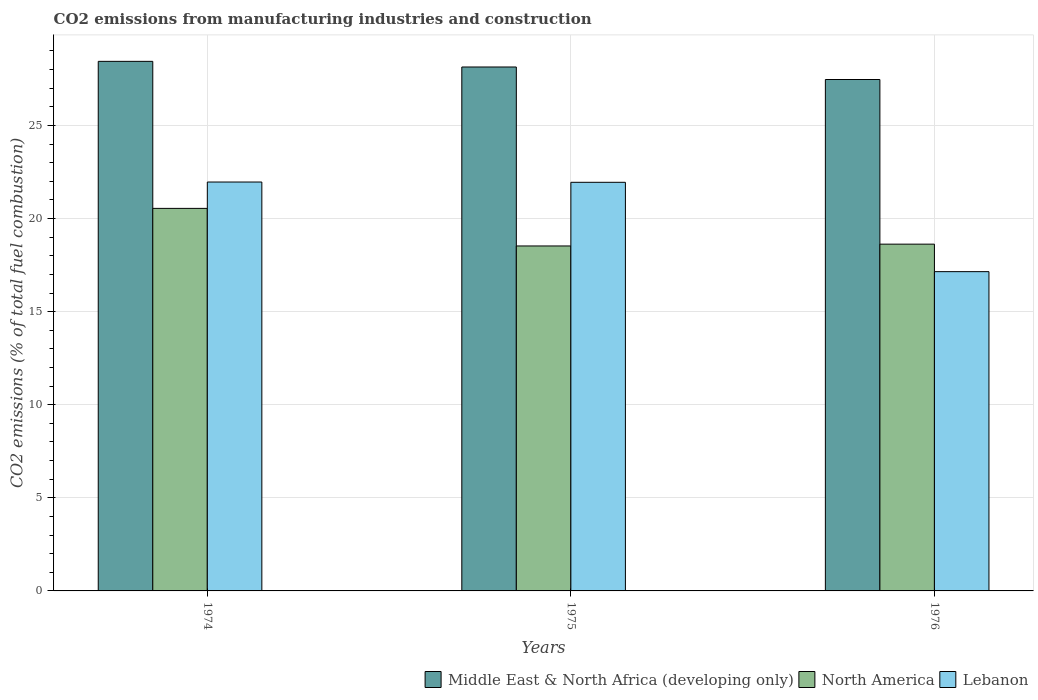How many different coloured bars are there?
Provide a short and direct response. 3. How many groups of bars are there?
Offer a very short reply. 3. Are the number of bars on each tick of the X-axis equal?
Ensure brevity in your answer.  Yes. What is the label of the 2nd group of bars from the left?
Offer a terse response. 1975. What is the amount of CO2 emitted in Lebanon in 1974?
Your answer should be very brief. 21.96. Across all years, what is the maximum amount of CO2 emitted in Middle East & North Africa (developing only)?
Provide a succinct answer. 28.44. Across all years, what is the minimum amount of CO2 emitted in Lebanon?
Keep it short and to the point. 17.15. In which year was the amount of CO2 emitted in North America maximum?
Provide a short and direct response. 1974. In which year was the amount of CO2 emitted in Lebanon minimum?
Your answer should be very brief. 1976. What is the total amount of CO2 emitted in Lebanon in the graph?
Offer a very short reply. 61.06. What is the difference between the amount of CO2 emitted in North America in 1974 and that in 1976?
Make the answer very short. 1.92. What is the difference between the amount of CO2 emitted in Middle East & North Africa (developing only) in 1975 and the amount of CO2 emitted in Lebanon in 1974?
Provide a succinct answer. 6.18. What is the average amount of CO2 emitted in Middle East & North Africa (developing only) per year?
Keep it short and to the point. 28.02. In the year 1975, what is the difference between the amount of CO2 emitted in Lebanon and amount of CO2 emitted in Middle East & North Africa (developing only)?
Provide a short and direct response. -6.19. In how many years, is the amount of CO2 emitted in Lebanon greater than 23 %?
Give a very brief answer. 0. What is the ratio of the amount of CO2 emitted in North America in 1975 to that in 1976?
Give a very brief answer. 0.99. Is the difference between the amount of CO2 emitted in Lebanon in 1974 and 1975 greater than the difference between the amount of CO2 emitted in Middle East & North Africa (developing only) in 1974 and 1975?
Keep it short and to the point. No. What is the difference between the highest and the second highest amount of CO2 emitted in Middle East & North Africa (developing only)?
Your response must be concise. 0.3. What is the difference between the highest and the lowest amount of CO2 emitted in Middle East & North Africa (developing only)?
Keep it short and to the point. 0.98. What does the 3rd bar from the right in 1974 represents?
Your answer should be very brief. Middle East & North Africa (developing only). How many years are there in the graph?
Keep it short and to the point. 3. Are the values on the major ticks of Y-axis written in scientific E-notation?
Your response must be concise. No. How many legend labels are there?
Your response must be concise. 3. How are the legend labels stacked?
Ensure brevity in your answer.  Horizontal. What is the title of the graph?
Keep it short and to the point. CO2 emissions from manufacturing industries and construction. Does "Gambia, The" appear as one of the legend labels in the graph?
Provide a succinct answer. No. What is the label or title of the Y-axis?
Give a very brief answer. CO2 emissions (% of total fuel combustion). What is the CO2 emissions (% of total fuel combustion) in Middle East & North Africa (developing only) in 1974?
Keep it short and to the point. 28.44. What is the CO2 emissions (% of total fuel combustion) of North America in 1974?
Keep it short and to the point. 20.55. What is the CO2 emissions (% of total fuel combustion) in Lebanon in 1974?
Your answer should be very brief. 21.96. What is the CO2 emissions (% of total fuel combustion) in Middle East & North Africa (developing only) in 1975?
Your answer should be compact. 28.14. What is the CO2 emissions (% of total fuel combustion) of North America in 1975?
Your response must be concise. 18.53. What is the CO2 emissions (% of total fuel combustion) of Lebanon in 1975?
Your answer should be very brief. 21.95. What is the CO2 emissions (% of total fuel combustion) of Middle East & North Africa (developing only) in 1976?
Offer a very short reply. 27.47. What is the CO2 emissions (% of total fuel combustion) in North America in 1976?
Make the answer very short. 18.63. What is the CO2 emissions (% of total fuel combustion) of Lebanon in 1976?
Offer a terse response. 17.15. Across all years, what is the maximum CO2 emissions (% of total fuel combustion) of Middle East & North Africa (developing only)?
Keep it short and to the point. 28.44. Across all years, what is the maximum CO2 emissions (% of total fuel combustion) in North America?
Provide a succinct answer. 20.55. Across all years, what is the maximum CO2 emissions (% of total fuel combustion) in Lebanon?
Offer a terse response. 21.96. Across all years, what is the minimum CO2 emissions (% of total fuel combustion) in Middle East & North Africa (developing only)?
Your answer should be very brief. 27.47. Across all years, what is the minimum CO2 emissions (% of total fuel combustion) of North America?
Keep it short and to the point. 18.53. Across all years, what is the minimum CO2 emissions (% of total fuel combustion) of Lebanon?
Keep it short and to the point. 17.15. What is the total CO2 emissions (% of total fuel combustion) of Middle East & North Africa (developing only) in the graph?
Make the answer very short. 84.05. What is the total CO2 emissions (% of total fuel combustion) of North America in the graph?
Your answer should be very brief. 57.7. What is the total CO2 emissions (% of total fuel combustion) in Lebanon in the graph?
Make the answer very short. 61.06. What is the difference between the CO2 emissions (% of total fuel combustion) of Middle East & North Africa (developing only) in 1974 and that in 1975?
Ensure brevity in your answer.  0.3. What is the difference between the CO2 emissions (% of total fuel combustion) in North America in 1974 and that in 1975?
Keep it short and to the point. 2.02. What is the difference between the CO2 emissions (% of total fuel combustion) in Lebanon in 1974 and that in 1975?
Offer a terse response. 0.02. What is the difference between the CO2 emissions (% of total fuel combustion) in Middle East & North Africa (developing only) in 1974 and that in 1976?
Ensure brevity in your answer.  0.97. What is the difference between the CO2 emissions (% of total fuel combustion) in North America in 1974 and that in 1976?
Give a very brief answer. 1.92. What is the difference between the CO2 emissions (% of total fuel combustion) in Lebanon in 1974 and that in 1976?
Offer a very short reply. 4.81. What is the difference between the CO2 emissions (% of total fuel combustion) in Middle East & North Africa (developing only) in 1975 and that in 1976?
Keep it short and to the point. 0.67. What is the difference between the CO2 emissions (% of total fuel combustion) in North America in 1975 and that in 1976?
Offer a very short reply. -0.1. What is the difference between the CO2 emissions (% of total fuel combustion) of Lebanon in 1975 and that in 1976?
Keep it short and to the point. 4.8. What is the difference between the CO2 emissions (% of total fuel combustion) of Middle East & North Africa (developing only) in 1974 and the CO2 emissions (% of total fuel combustion) of North America in 1975?
Keep it short and to the point. 9.92. What is the difference between the CO2 emissions (% of total fuel combustion) of Middle East & North Africa (developing only) in 1974 and the CO2 emissions (% of total fuel combustion) of Lebanon in 1975?
Your answer should be very brief. 6.5. What is the difference between the CO2 emissions (% of total fuel combustion) in North America in 1974 and the CO2 emissions (% of total fuel combustion) in Lebanon in 1975?
Keep it short and to the point. -1.4. What is the difference between the CO2 emissions (% of total fuel combustion) in Middle East & North Africa (developing only) in 1974 and the CO2 emissions (% of total fuel combustion) in North America in 1976?
Make the answer very short. 9.82. What is the difference between the CO2 emissions (% of total fuel combustion) in Middle East & North Africa (developing only) in 1974 and the CO2 emissions (% of total fuel combustion) in Lebanon in 1976?
Provide a short and direct response. 11.3. What is the difference between the CO2 emissions (% of total fuel combustion) in North America in 1974 and the CO2 emissions (% of total fuel combustion) in Lebanon in 1976?
Make the answer very short. 3.4. What is the difference between the CO2 emissions (% of total fuel combustion) in Middle East & North Africa (developing only) in 1975 and the CO2 emissions (% of total fuel combustion) in North America in 1976?
Offer a very short reply. 9.52. What is the difference between the CO2 emissions (% of total fuel combustion) in Middle East & North Africa (developing only) in 1975 and the CO2 emissions (% of total fuel combustion) in Lebanon in 1976?
Provide a short and direct response. 10.99. What is the difference between the CO2 emissions (% of total fuel combustion) in North America in 1975 and the CO2 emissions (% of total fuel combustion) in Lebanon in 1976?
Keep it short and to the point. 1.38. What is the average CO2 emissions (% of total fuel combustion) in Middle East & North Africa (developing only) per year?
Provide a succinct answer. 28.02. What is the average CO2 emissions (% of total fuel combustion) of North America per year?
Keep it short and to the point. 19.23. What is the average CO2 emissions (% of total fuel combustion) in Lebanon per year?
Provide a short and direct response. 20.35. In the year 1974, what is the difference between the CO2 emissions (% of total fuel combustion) of Middle East & North Africa (developing only) and CO2 emissions (% of total fuel combustion) of North America?
Keep it short and to the point. 7.9. In the year 1974, what is the difference between the CO2 emissions (% of total fuel combustion) of Middle East & North Africa (developing only) and CO2 emissions (% of total fuel combustion) of Lebanon?
Provide a short and direct response. 6.48. In the year 1974, what is the difference between the CO2 emissions (% of total fuel combustion) in North America and CO2 emissions (% of total fuel combustion) in Lebanon?
Ensure brevity in your answer.  -1.42. In the year 1975, what is the difference between the CO2 emissions (% of total fuel combustion) in Middle East & North Africa (developing only) and CO2 emissions (% of total fuel combustion) in North America?
Offer a very short reply. 9.61. In the year 1975, what is the difference between the CO2 emissions (% of total fuel combustion) of Middle East & North Africa (developing only) and CO2 emissions (% of total fuel combustion) of Lebanon?
Provide a short and direct response. 6.19. In the year 1975, what is the difference between the CO2 emissions (% of total fuel combustion) in North America and CO2 emissions (% of total fuel combustion) in Lebanon?
Provide a short and direct response. -3.42. In the year 1976, what is the difference between the CO2 emissions (% of total fuel combustion) in Middle East & North Africa (developing only) and CO2 emissions (% of total fuel combustion) in North America?
Provide a succinct answer. 8.84. In the year 1976, what is the difference between the CO2 emissions (% of total fuel combustion) in Middle East & North Africa (developing only) and CO2 emissions (% of total fuel combustion) in Lebanon?
Offer a very short reply. 10.32. In the year 1976, what is the difference between the CO2 emissions (% of total fuel combustion) of North America and CO2 emissions (% of total fuel combustion) of Lebanon?
Your response must be concise. 1.48. What is the ratio of the CO2 emissions (% of total fuel combustion) of Middle East & North Africa (developing only) in 1974 to that in 1975?
Offer a very short reply. 1.01. What is the ratio of the CO2 emissions (% of total fuel combustion) in North America in 1974 to that in 1975?
Your response must be concise. 1.11. What is the ratio of the CO2 emissions (% of total fuel combustion) of Middle East & North Africa (developing only) in 1974 to that in 1976?
Offer a very short reply. 1.04. What is the ratio of the CO2 emissions (% of total fuel combustion) in North America in 1974 to that in 1976?
Offer a terse response. 1.1. What is the ratio of the CO2 emissions (% of total fuel combustion) in Lebanon in 1974 to that in 1976?
Provide a succinct answer. 1.28. What is the ratio of the CO2 emissions (% of total fuel combustion) in Middle East & North Africa (developing only) in 1975 to that in 1976?
Your response must be concise. 1.02. What is the ratio of the CO2 emissions (% of total fuel combustion) in North America in 1975 to that in 1976?
Your answer should be very brief. 0.99. What is the ratio of the CO2 emissions (% of total fuel combustion) of Lebanon in 1975 to that in 1976?
Your answer should be compact. 1.28. What is the difference between the highest and the second highest CO2 emissions (% of total fuel combustion) in Middle East & North Africa (developing only)?
Ensure brevity in your answer.  0.3. What is the difference between the highest and the second highest CO2 emissions (% of total fuel combustion) in North America?
Your response must be concise. 1.92. What is the difference between the highest and the second highest CO2 emissions (% of total fuel combustion) in Lebanon?
Offer a terse response. 0.02. What is the difference between the highest and the lowest CO2 emissions (% of total fuel combustion) of Middle East & North Africa (developing only)?
Your response must be concise. 0.97. What is the difference between the highest and the lowest CO2 emissions (% of total fuel combustion) of North America?
Keep it short and to the point. 2.02. What is the difference between the highest and the lowest CO2 emissions (% of total fuel combustion) in Lebanon?
Provide a short and direct response. 4.81. 